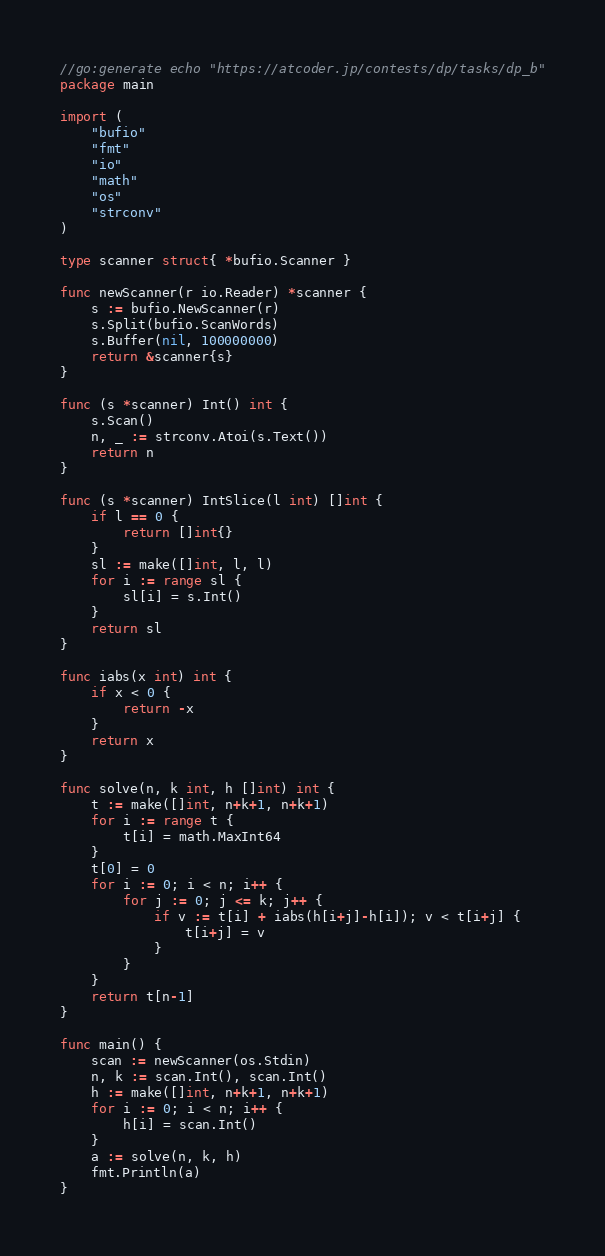<code> <loc_0><loc_0><loc_500><loc_500><_Go_>//go:generate echo "https://atcoder.jp/contests/dp/tasks/dp_b"
package main

import (
	"bufio"
	"fmt"
	"io"
	"math"
	"os"
	"strconv"
)

type scanner struct{ *bufio.Scanner }

func newScanner(r io.Reader) *scanner {
	s := bufio.NewScanner(r)
	s.Split(bufio.ScanWords)
	s.Buffer(nil, 100000000)
	return &scanner{s}
}

func (s *scanner) Int() int {
	s.Scan()
	n, _ := strconv.Atoi(s.Text())
	return n
}

func (s *scanner) IntSlice(l int) []int {
	if l == 0 {
		return []int{}
	}
	sl := make([]int, l, l)
	for i := range sl {
		sl[i] = s.Int()
	}
	return sl
}

func iabs(x int) int {
	if x < 0 {
		return -x
	}
	return x
}

func solve(n, k int, h []int) int {
	t := make([]int, n+k+1, n+k+1)
	for i := range t {
		t[i] = math.MaxInt64
	}
	t[0] = 0
	for i := 0; i < n; i++ {
		for j := 0; j <= k; j++ {
			if v := t[i] + iabs(h[i+j]-h[i]); v < t[i+j] {
				t[i+j] = v
			}
		}
	}
	return t[n-1]
}

func main() {
	scan := newScanner(os.Stdin)
	n, k := scan.Int(), scan.Int()
	h := make([]int, n+k+1, n+k+1)
	for i := 0; i < n; i++ {
		h[i] = scan.Int()
	}
	a := solve(n, k, h)
	fmt.Println(a)
}
</code> 